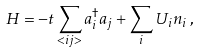Convert formula to latex. <formula><loc_0><loc_0><loc_500><loc_500>H = - t \sum _ { < i j > } a _ { i } ^ { \dag } a _ { j } + \sum _ { i } U _ { i } n _ { i } \, ,</formula> 